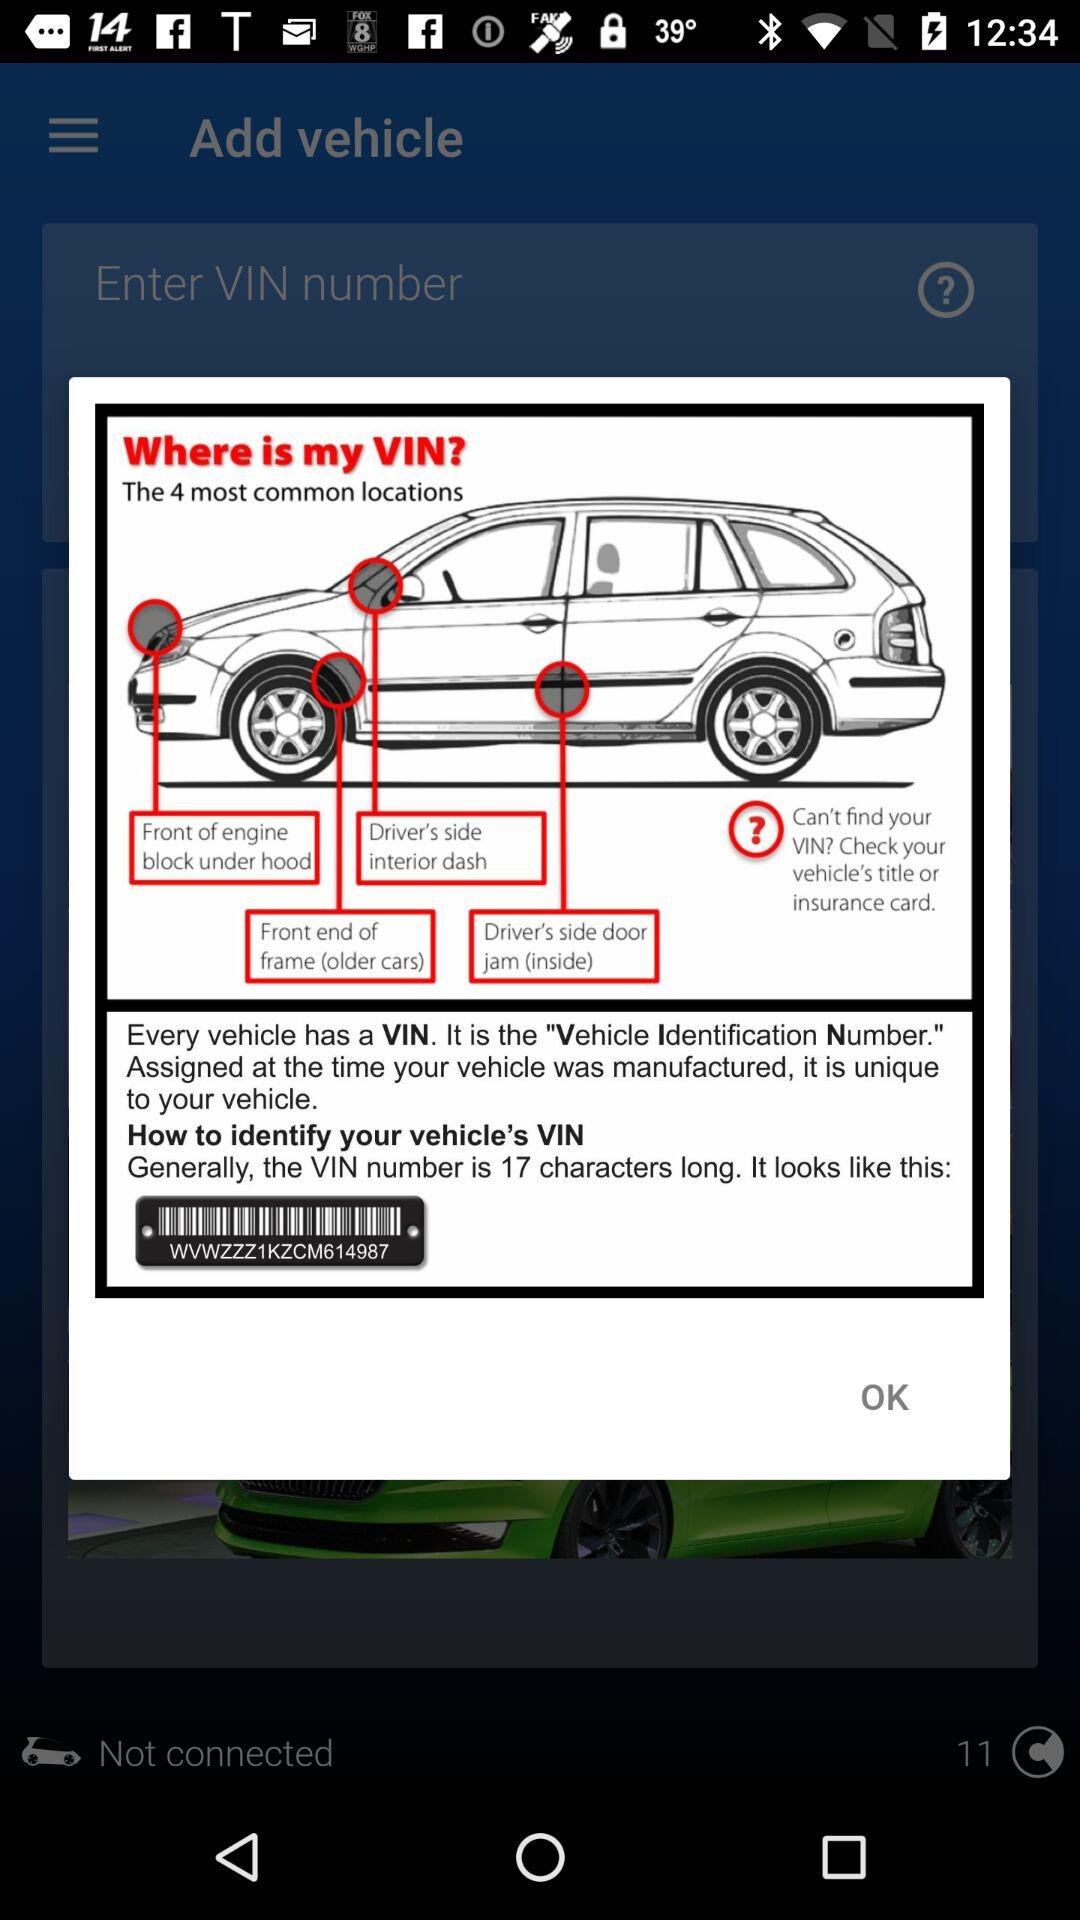How many locations are there for the VIN?
Answer the question using a single word or phrase. 4 